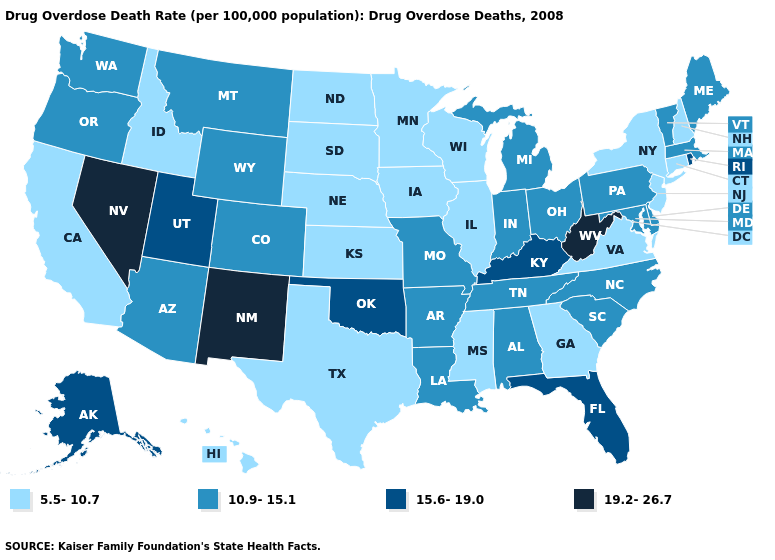Name the states that have a value in the range 19.2-26.7?
Short answer required. Nevada, New Mexico, West Virginia. What is the highest value in states that border Colorado?
Short answer required. 19.2-26.7. Does Tennessee have a higher value than California?
Give a very brief answer. Yes. Among the states that border West Virginia , which have the highest value?
Answer briefly. Kentucky. What is the value of Minnesota?
Short answer required. 5.5-10.7. What is the highest value in the West ?
Give a very brief answer. 19.2-26.7. Name the states that have a value in the range 10.9-15.1?
Quick response, please. Alabama, Arizona, Arkansas, Colorado, Delaware, Indiana, Louisiana, Maine, Maryland, Massachusetts, Michigan, Missouri, Montana, North Carolina, Ohio, Oregon, Pennsylvania, South Carolina, Tennessee, Vermont, Washington, Wyoming. Does Pennsylvania have the lowest value in the USA?
Concise answer only. No. Does the map have missing data?
Give a very brief answer. No. What is the value of Alabama?
Write a very short answer. 10.9-15.1. What is the value of Delaware?
Short answer required. 10.9-15.1. Does Georgia have a lower value than Missouri?
Answer briefly. Yes. Which states have the lowest value in the West?
Concise answer only. California, Hawaii, Idaho. Is the legend a continuous bar?
Quick response, please. No. Name the states that have a value in the range 15.6-19.0?
Be succinct. Alaska, Florida, Kentucky, Oklahoma, Rhode Island, Utah. 